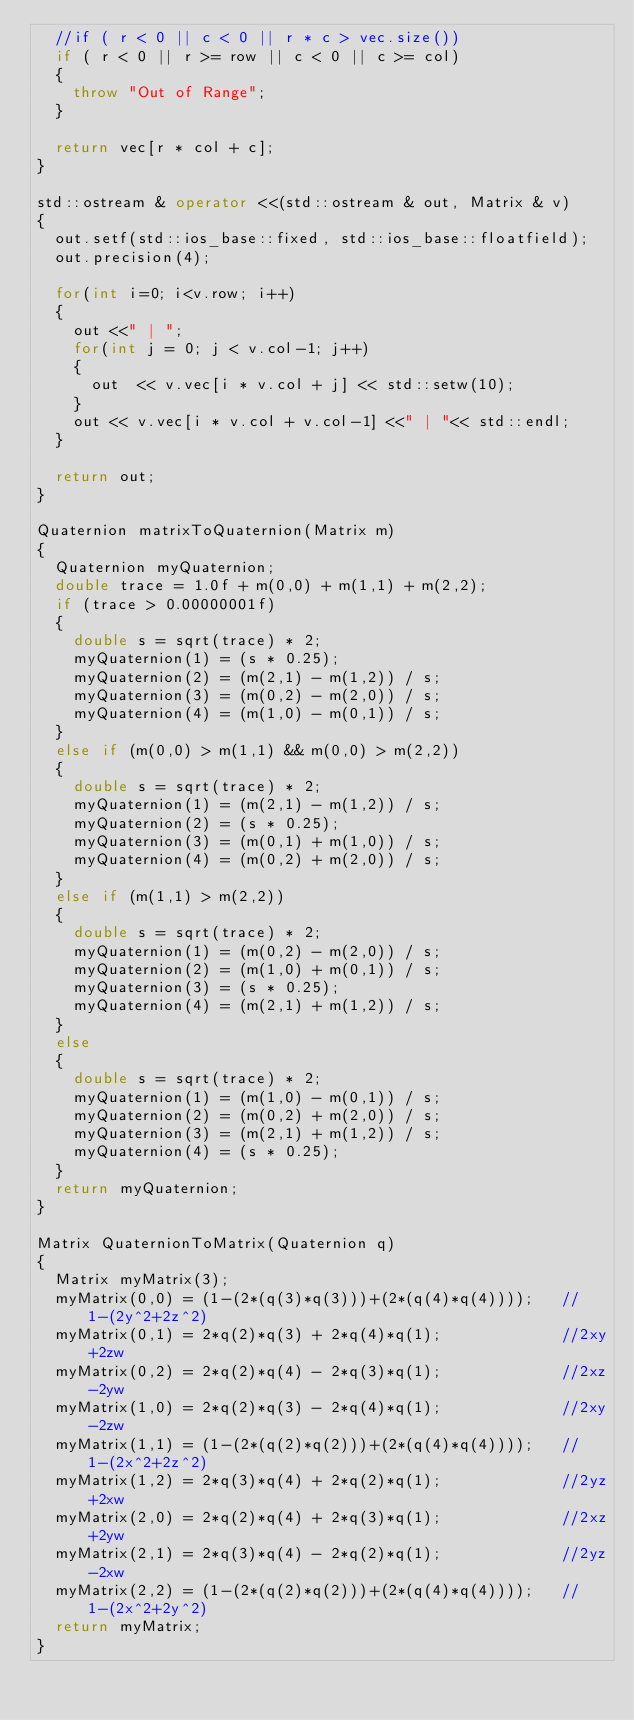<code> <loc_0><loc_0><loc_500><loc_500><_C++_>	//if ( r < 0 || c < 0 || r * c > vec.size())
	if ( r < 0 || r >= row || c < 0 || c >= col)
	{
		throw "Out of Range";
	}

	return vec[r * col + c]; 
}

std::ostream & operator <<(std::ostream & out, Matrix & v)
{
	out.setf(std::ios_base::fixed, std::ios_base::floatfield);
	out.precision(4);

	for(int i=0; i<v.row; i++)
	{
		out <<" | ";
		for(int j = 0; j < v.col-1; j++)
		{
			out  << v.vec[i * v.col + j] << std::setw(10);
		}
		out << v.vec[i * v.col + v.col-1] <<" | "<< std::endl;
	}

	return out;
}

Quaternion matrixToQuaternion(Matrix m)
{
	Quaternion myQuaternion;
	double trace = 1.0f + m(0,0) + m(1,1) + m(2,2);
	if (trace > 0.00000001f)	
	{
		double s = sqrt(trace) * 2;
		myQuaternion(1) = (s * 0.25);
		myQuaternion(2) = (m(2,1) - m(1,2)) / s;
		myQuaternion(3) = (m(0,2) - m(2,0)) / s;
		myQuaternion(4) = (m(1,0) - m(0,1)) / s;
	}	
	else if (m(0,0) > m(1,1) && m(0,0) > m(2,2))	
	{		
		double s = sqrt(trace) * 2;
		myQuaternion(1) = (m(2,1) - m(1,2)) / s;
		myQuaternion(2) = (s * 0.25);
		myQuaternion(3) = (m(0,1) + m(1,0)) / s;
		myQuaternion(4) = (m(0,2) + m(2,0)) / s;
	}	
	else if (m(1,1) > m(2,2))	
	{		
		double s = sqrt(trace) * 2;
		myQuaternion(1) = (m(0,2) - m(2,0)) / s;
		myQuaternion(2) = (m(1,0) + m(0,1)) / s;
		myQuaternion(3) = (s * 0.25);
		myQuaternion(4) = (m(2,1) + m(1,2)) / s;
	}	
	else	
	{		
		double s = sqrt(trace) * 2;
		myQuaternion(1) = (m(1,0) - m(0,1)) / s;
		myQuaternion(2) = (m(0,2) + m(2,0)) / s;
		myQuaternion(3) = (m(2,1) + m(1,2)) / s;
		myQuaternion(4) = (s * 0.25);
	}
	return myQuaternion;
}

Matrix QuaternionToMatrix(Quaternion q)
{
	Matrix myMatrix(3);
	myMatrix(0,0) = (1-(2*(q(3)*q(3)))+(2*(q(4)*q(4))));   //1-(2y^2+2z^2)
	myMatrix(0,1) = 2*q(2)*q(3) + 2*q(4)*q(1);             //2xy+2zw
	myMatrix(0,2) = 2*q(2)*q(4) - 2*q(3)*q(1);             //2xz-2yw
	myMatrix(1,0) = 2*q(2)*q(3) - 2*q(4)*q(1);             //2xy-2zw
	myMatrix(1,1) = (1-(2*(q(2)*q(2)))+(2*(q(4)*q(4))));   //1-(2x^2+2z^2)
	myMatrix(1,2) = 2*q(3)*q(4) + 2*q(2)*q(1);             //2yz+2xw
	myMatrix(2,0) = 2*q(2)*q(4) + 2*q(3)*q(1);             //2xz+2yw
	myMatrix(2,1) = 2*q(3)*q(4) - 2*q(2)*q(1);             //2yz-2xw
	myMatrix(2,2) = (1-(2*(q(2)*q(2)))+(2*(q(4)*q(4))));   //1-(2x^2+2y^2)
	return myMatrix;
}</code> 